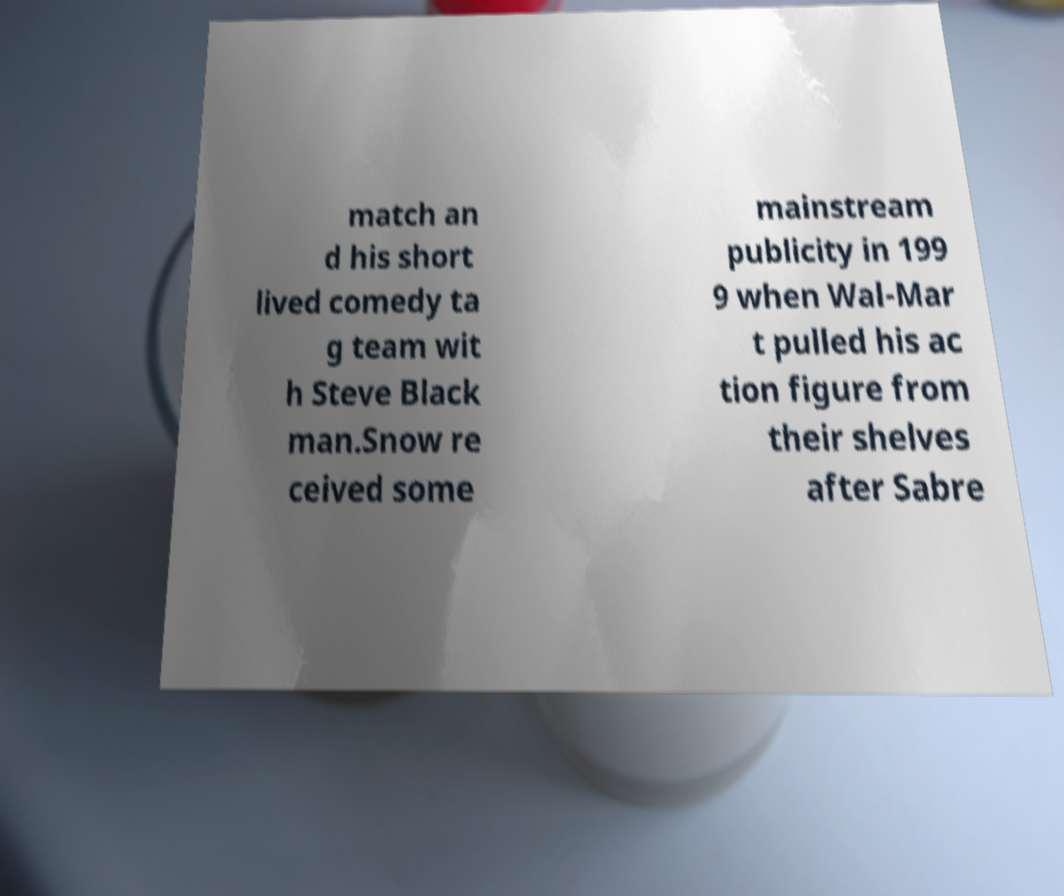Can you accurately transcribe the text from the provided image for me? match an d his short lived comedy ta g team wit h Steve Black man.Snow re ceived some mainstream publicity in 199 9 when Wal-Mar t pulled his ac tion figure from their shelves after Sabre 